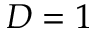<formula> <loc_0><loc_0><loc_500><loc_500>D = 1</formula> 